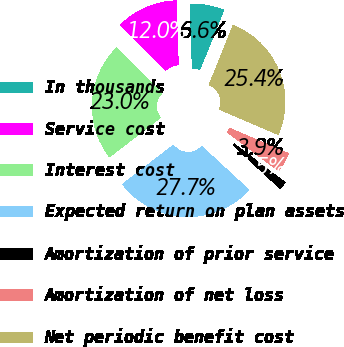Convert chart. <chart><loc_0><loc_0><loc_500><loc_500><pie_chart><fcel>In thousands<fcel>Service cost<fcel>Interest cost<fcel>Expected return on plan assets<fcel>Amortization of prior service<fcel>Amortization of net loss<fcel>Net periodic benefit cost<nl><fcel>6.59%<fcel>11.95%<fcel>22.97%<fcel>27.72%<fcel>1.52%<fcel>3.89%<fcel>25.35%<nl></chart> 